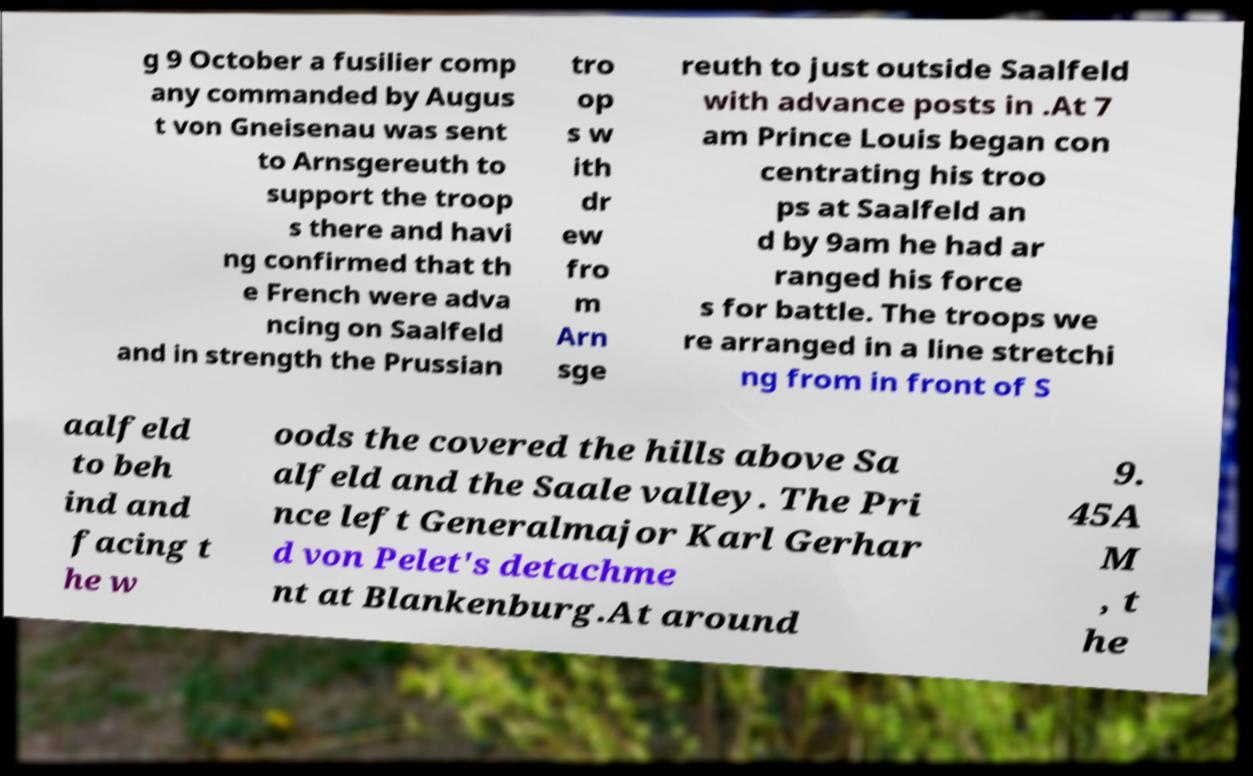Could you assist in decoding the text presented in this image and type it out clearly? g 9 October a fusilier comp any commanded by Augus t von Gneisenau was sent to Arnsgereuth to support the troop s there and havi ng confirmed that th e French were adva ncing on Saalfeld and in strength the Prussian tro op s w ith dr ew fro m Arn sge reuth to just outside Saalfeld with advance posts in .At 7 am Prince Louis began con centrating his troo ps at Saalfeld an d by 9am he had ar ranged his force s for battle. The troops we re arranged in a line stretchi ng from in front of S aalfeld to beh ind and facing t he w oods the covered the hills above Sa alfeld and the Saale valley. The Pri nce left Generalmajor Karl Gerhar d von Pelet's detachme nt at Blankenburg.At around 9. 45A M , t he 